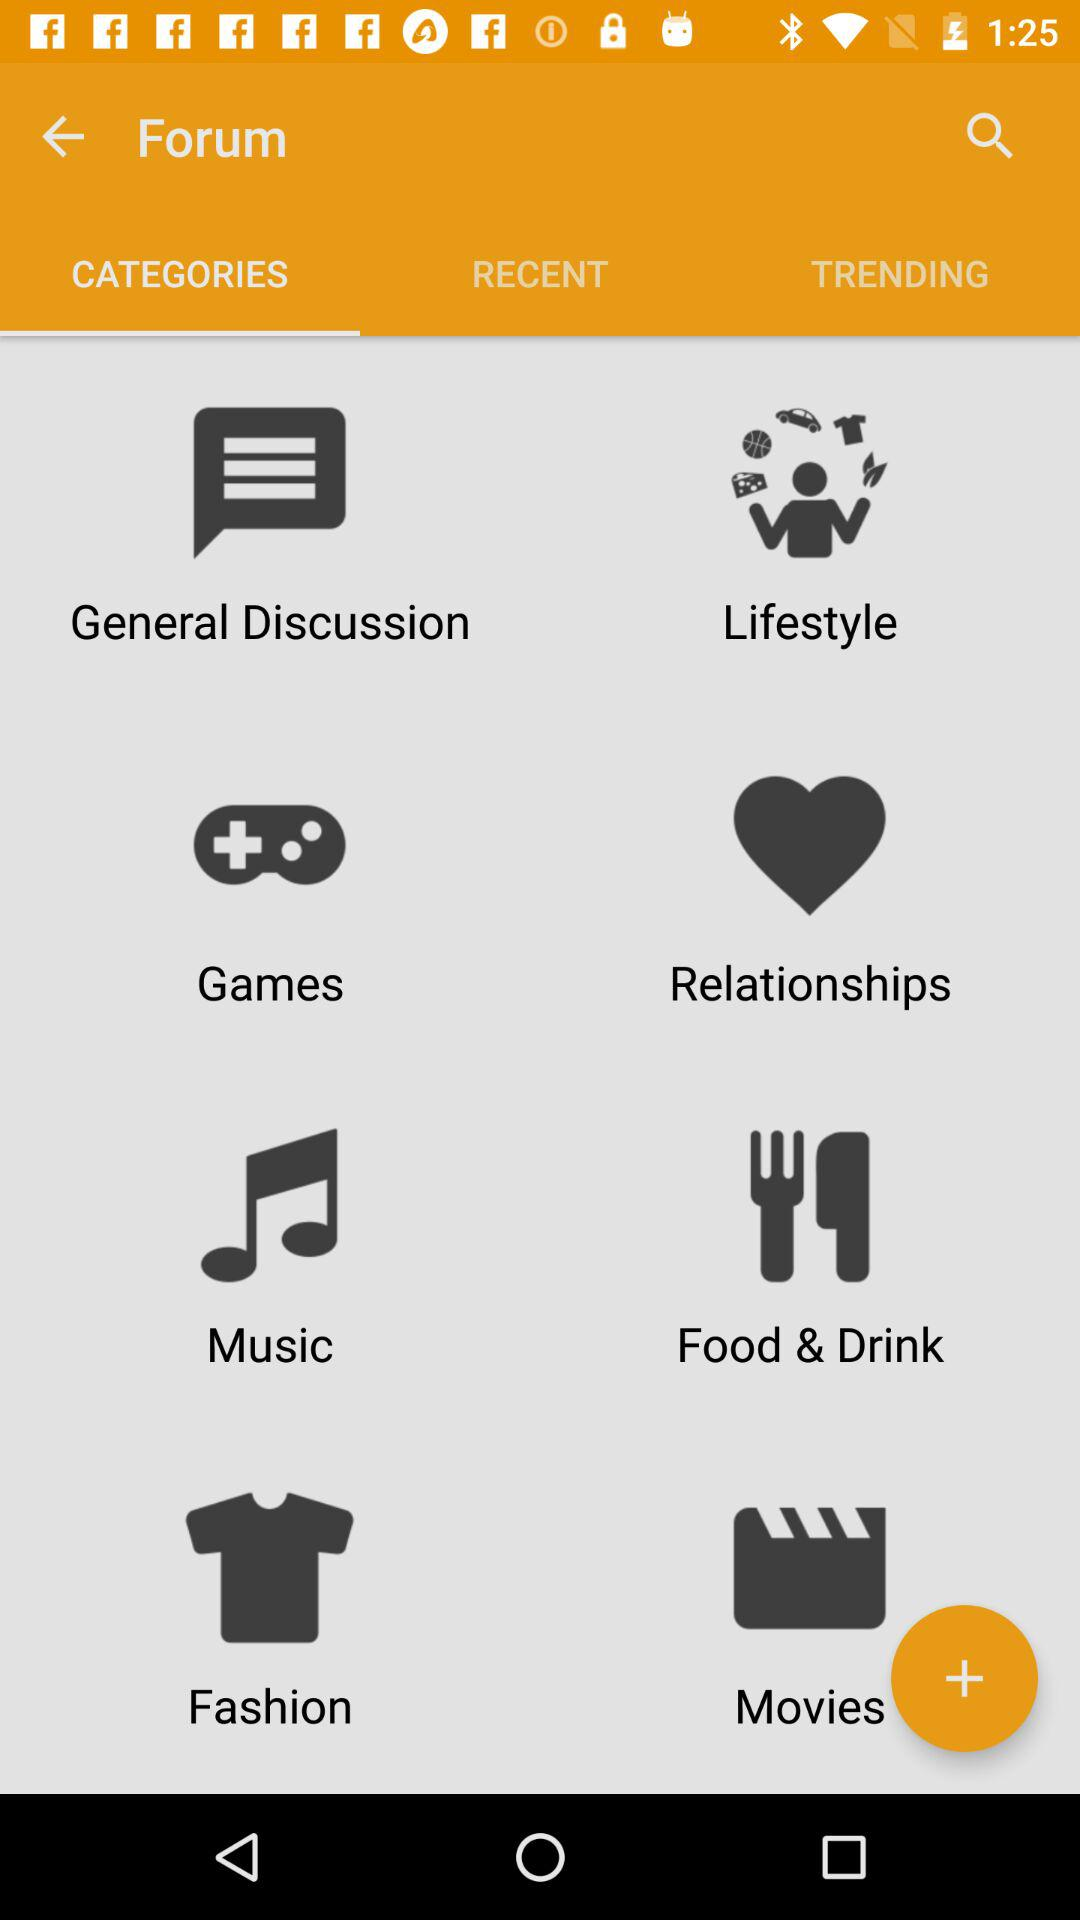Which option is selected in "Forum"? The selected option in "Forum" is "CATEGORIES". 